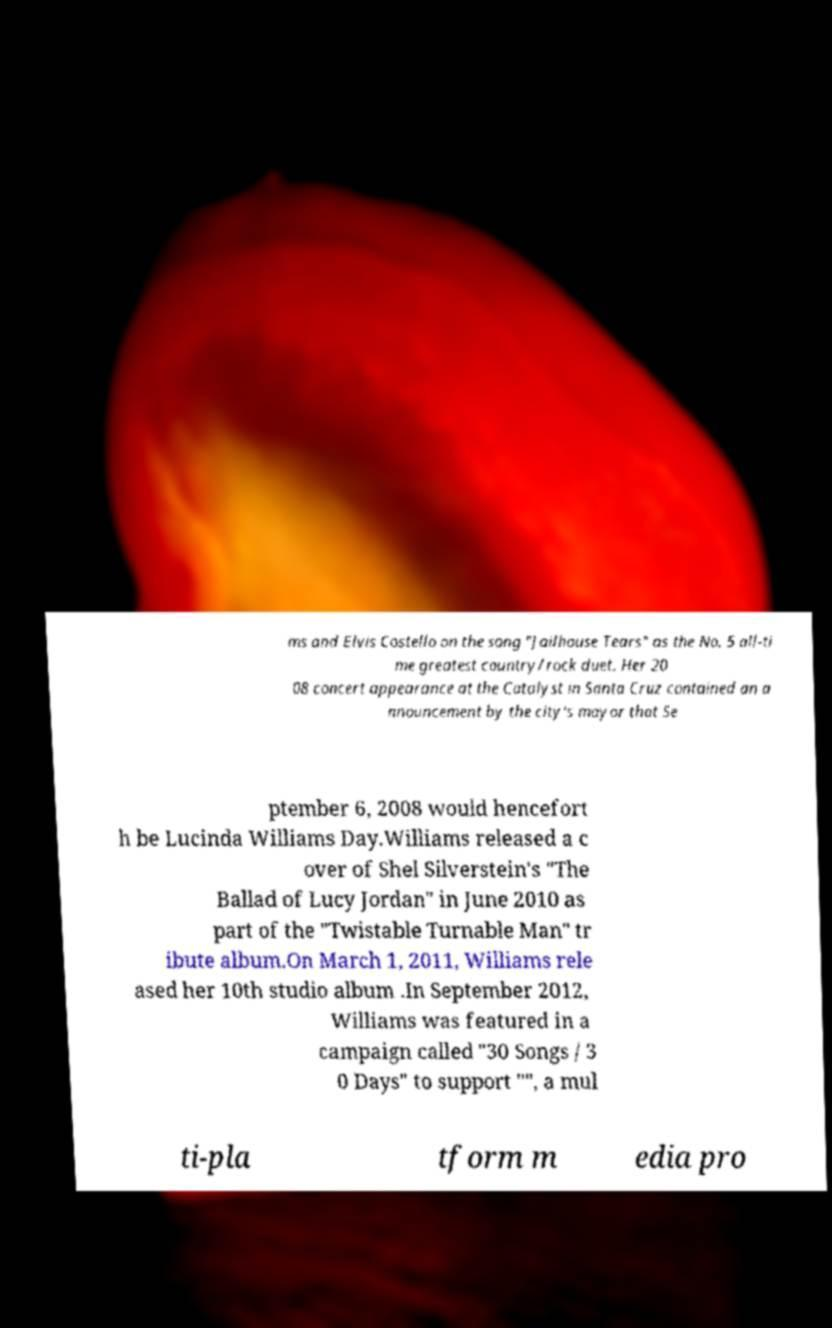Could you assist in decoding the text presented in this image and type it out clearly? ms and Elvis Costello on the song "Jailhouse Tears" as the No. 5 all-ti me greatest country/rock duet. Her 20 08 concert appearance at the Catalyst in Santa Cruz contained an a nnouncement by the city's mayor that Se ptember 6, 2008 would hencefort h be Lucinda Williams Day.Williams released a c over of Shel Silverstein's "The Ballad of Lucy Jordan" in June 2010 as part of the "Twistable Turnable Man" tr ibute album.On March 1, 2011, Williams rele ased her 10th studio album .In September 2012, Williams was featured in a campaign called "30 Songs / 3 0 Days" to support "", a mul ti-pla tform m edia pro 